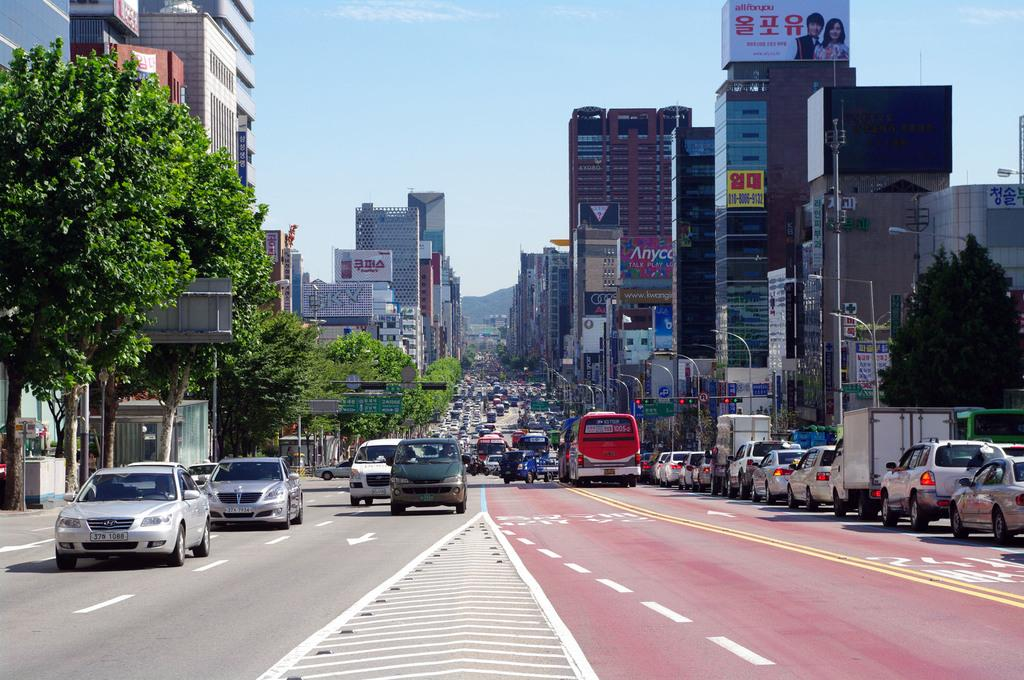What type of structures can be seen in the image? There are buildings in the image. What is happening on the road in the image? There are vehicles on the road in the image. What can be seen on the road to guide traffic? There are road marks and traffic signals in the image. What helps to illuminate the road at night? There are street lights in the image. What type of vegetation is present in the image? There are trees in the image. What is visible in the background of the image? The sky is visible in the image. Can you see the edge of the guitar in the image? There is no guitar present in the image. What type of start can be seen in the image? There is no start or race depicted in the image; it features buildings, vehicles, road marks, traffic signals, street lights, trees, and the sky. 